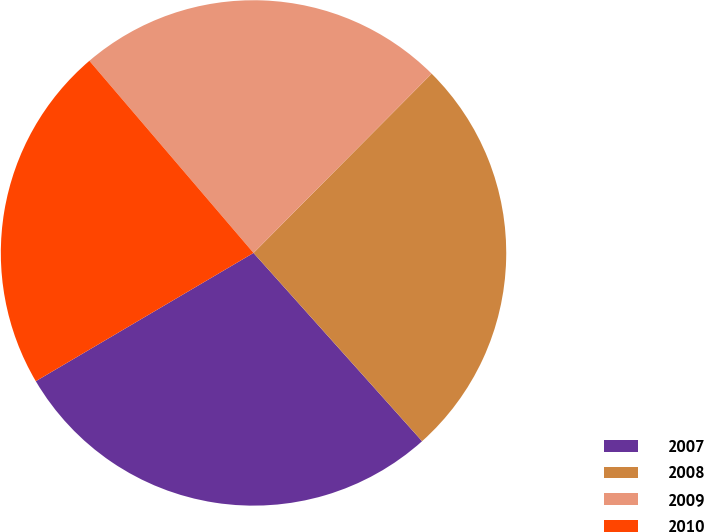Convert chart. <chart><loc_0><loc_0><loc_500><loc_500><pie_chart><fcel>2007<fcel>2008<fcel>2009<fcel>2010<nl><fcel>28.15%<fcel>25.93%<fcel>23.7%<fcel>22.22%<nl></chart> 